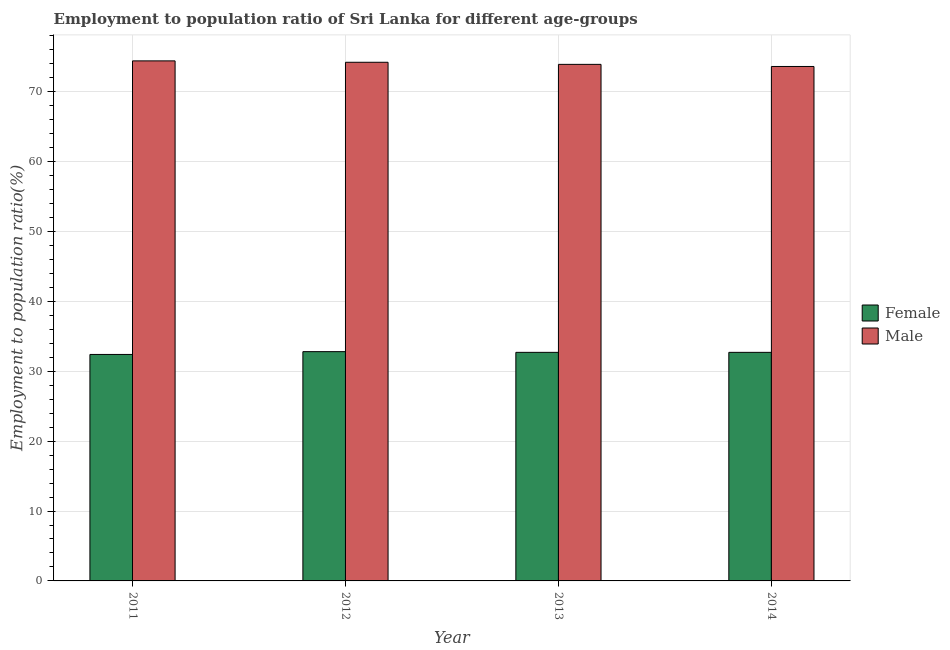How many groups of bars are there?
Your response must be concise. 4. Are the number of bars per tick equal to the number of legend labels?
Your answer should be very brief. Yes. How many bars are there on the 3rd tick from the left?
Make the answer very short. 2. How many bars are there on the 2nd tick from the right?
Your answer should be very brief. 2. What is the employment to population ratio(male) in 2014?
Provide a short and direct response. 73.6. Across all years, what is the maximum employment to population ratio(male)?
Offer a terse response. 74.4. Across all years, what is the minimum employment to population ratio(male)?
Ensure brevity in your answer.  73.6. In which year was the employment to population ratio(male) minimum?
Your answer should be compact. 2014. What is the total employment to population ratio(female) in the graph?
Keep it short and to the point. 130.6. What is the difference between the employment to population ratio(female) in 2011 and that in 2012?
Your answer should be very brief. -0.4. What is the difference between the employment to population ratio(female) in 2012 and the employment to population ratio(male) in 2014?
Your answer should be compact. 0.1. What is the average employment to population ratio(female) per year?
Provide a short and direct response. 32.65. What is the ratio of the employment to population ratio(male) in 2011 to that in 2012?
Offer a very short reply. 1. Is the employment to population ratio(female) in 2012 less than that in 2014?
Offer a very short reply. No. What is the difference between the highest and the second highest employment to population ratio(female)?
Keep it short and to the point. 0.1. What is the difference between the highest and the lowest employment to population ratio(female)?
Give a very brief answer. 0.4. In how many years, is the employment to population ratio(male) greater than the average employment to population ratio(male) taken over all years?
Offer a very short reply. 2. Is the sum of the employment to population ratio(male) in 2012 and 2014 greater than the maximum employment to population ratio(female) across all years?
Provide a succinct answer. Yes. Are all the bars in the graph horizontal?
Your response must be concise. No. Are the values on the major ticks of Y-axis written in scientific E-notation?
Provide a succinct answer. No. Does the graph contain grids?
Provide a short and direct response. Yes. How are the legend labels stacked?
Your answer should be compact. Vertical. What is the title of the graph?
Make the answer very short. Employment to population ratio of Sri Lanka for different age-groups. Does "Primary education" appear as one of the legend labels in the graph?
Make the answer very short. No. What is the Employment to population ratio(%) of Female in 2011?
Offer a terse response. 32.4. What is the Employment to population ratio(%) of Male in 2011?
Your answer should be compact. 74.4. What is the Employment to population ratio(%) in Female in 2012?
Your answer should be very brief. 32.8. What is the Employment to population ratio(%) of Male in 2012?
Offer a terse response. 74.2. What is the Employment to population ratio(%) of Female in 2013?
Your answer should be compact. 32.7. What is the Employment to population ratio(%) in Male in 2013?
Your response must be concise. 73.9. What is the Employment to population ratio(%) of Female in 2014?
Give a very brief answer. 32.7. What is the Employment to population ratio(%) of Male in 2014?
Ensure brevity in your answer.  73.6. Across all years, what is the maximum Employment to population ratio(%) in Female?
Provide a short and direct response. 32.8. Across all years, what is the maximum Employment to population ratio(%) of Male?
Ensure brevity in your answer.  74.4. Across all years, what is the minimum Employment to population ratio(%) in Female?
Your answer should be compact. 32.4. Across all years, what is the minimum Employment to population ratio(%) in Male?
Your response must be concise. 73.6. What is the total Employment to population ratio(%) in Female in the graph?
Your answer should be compact. 130.6. What is the total Employment to population ratio(%) of Male in the graph?
Provide a succinct answer. 296.1. What is the difference between the Employment to population ratio(%) in Female in 2011 and that in 2012?
Your response must be concise. -0.4. What is the difference between the Employment to population ratio(%) of Female in 2011 and that in 2013?
Offer a very short reply. -0.3. What is the difference between the Employment to population ratio(%) in Male in 2011 and that in 2013?
Your answer should be compact. 0.5. What is the difference between the Employment to population ratio(%) in Female in 2012 and that in 2014?
Make the answer very short. 0.1. What is the difference between the Employment to population ratio(%) of Male in 2012 and that in 2014?
Provide a short and direct response. 0.6. What is the difference between the Employment to population ratio(%) of Female in 2011 and the Employment to population ratio(%) of Male in 2012?
Ensure brevity in your answer.  -41.8. What is the difference between the Employment to population ratio(%) of Female in 2011 and the Employment to population ratio(%) of Male in 2013?
Your answer should be compact. -41.5. What is the difference between the Employment to population ratio(%) in Female in 2011 and the Employment to population ratio(%) in Male in 2014?
Your answer should be very brief. -41.2. What is the difference between the Employment to population ratio(%) of Female in 2012 and the Employment to population ratio(%) of Male in 2013?
Provide a short and direct response. -41.1. What is the difference between the Employment to population ratio(%) in Female in 2012 and the Employment to population ratio(%) in Male in 2014?
Give a very brief answer. -40.8. What is the difference between the Employment to population ratio(%) of Female in 2013 and the Employment to population ratio(%) of Male in 2014?
Provide a succinct answer. -40.9. What is the average Employment to population ratio(%) of Female per year?
Offer a terse response. 32.65. What is the average Employment to population ratio(%) in Male per year?
Keep it short and to the point. 74.03. In the year 2011, what is the difference between the Employment to population ratio(%) in Female and Employment to population ratio(%) in Male?
Provide a short and direct response. -42. In the year 2012, what is the difference between the Employment to population ratio(%) of Female and Employment to population ratio(%) of Male?
Make the answer very short. -41.4. In the year 2013, what is the difference between the Employment to population ratio(%) of Female and Employment to population ratio(%) of Male?
Provide a short and direct response. -41.2. In the year 2014, what is the difference between the Employment to population ratio(%) in Female and Employment to population ratio(%) in Male?
Offer a very short reply. -40.9. What is the ratio of the Employment to population ratio(%) of Female in 2011 to that in 2012?
Provide a short and direct response. 0.99. What is the ratio of the Employment to population ratio(%) of Female in 2011 to that in 2013?
Offer a terse response. 0.99. What is the ratio of the Employment to population ratio(%) in Male in 2011 to that in 2013?
Offer a very short reply. 1.01. What is the ratio of the Employment to population ratio(%) in Male in 2011 to that in 2014?
Your answer should be very brief. 1.01. What is the ratio of the Employment to population ratio(%) of Female in 2012 to that in 2013?
Give a very brief answer. 1. What is the ratio of the Employment to population ratio(%) of Male in 2012 to that in 2013?
Your answer should be very brief. 1. What is the ratio of the Employment to population ratio(%) in Male in 2012 to that in 2014?
Your answer should be very brief. 1.01. What is the ratio of the Employment to population ratio(%) in Female in 2013 to that in 2014?
Ensure brevity in your answer.  1. What is the difference between the highest and the second highest Employment to population ratio(%) in Female?
Keep it short and to the point. 0.1. What is the difference between the highest and the second highest Employment to population ratio(%) of Male?
Give a very brief answer. 0.2. What is the difference between the highest and the lowest Employment to population ratio(%) of Male?
Keep it short and to the point. 0.8. 